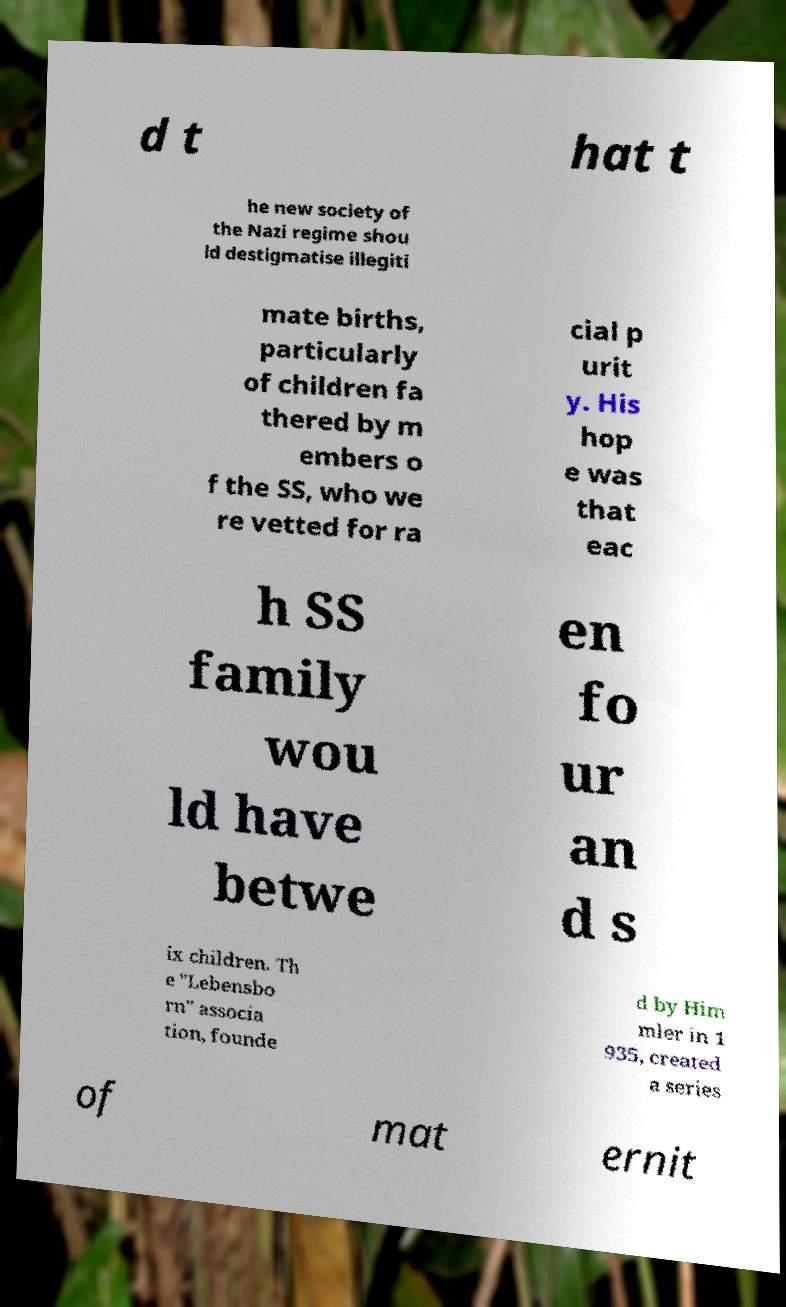For documentation purposes, I need the text within this image transcribed. Could you provide that? d t hat t he new society of the Nazi regime shou ld destigmatise illegiti mate births, particularly of children fa thered by m embers o f the SS, who we re vetted for ra cial p urit y. His hop e was that eac h SS family wou ld have betwe en fo ur an d s ix children. Th e "Lebensbo rn" associa tion, founde d by Him mler in 1 935, created a series of mat ernit 